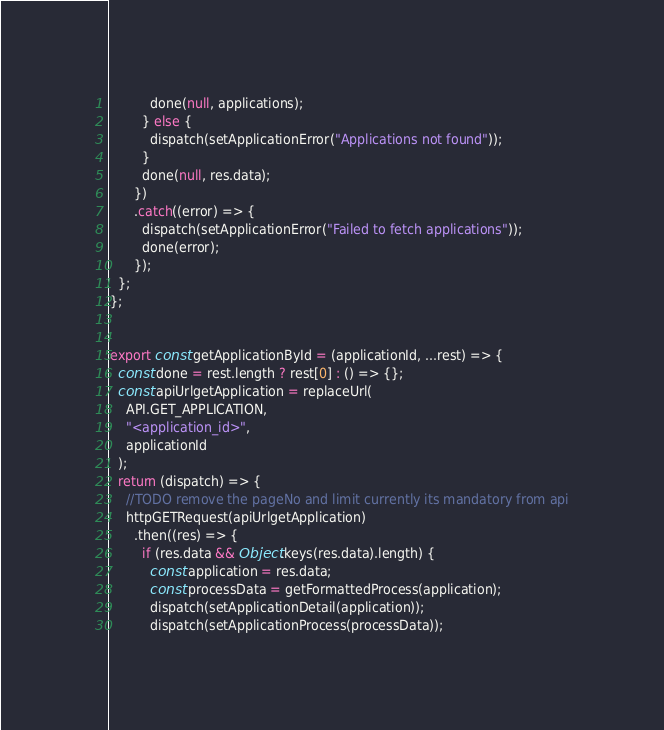Convert code to text. <code><loc_0><loc_0><loc_500><loc_500><_JavaScript_>          done(null, applications);
        } else {
          dispatch(setApplicationError("Applications not found"));
        }
        done(null, res.data);
      })
      .catch((error) => {
        dispatch(setApplicationError("Failed to fetch applications"));
        done(error);
      });
  };
};


export const getApplicationById = (applicationId, ...rest) => {
  const done = rest.length ? rest[0] : () => {};
  const apiUrlgetApplication = replaceUrl(
    API.GET_APPLICATION,
    "<application_id>",
    applicationId
  );
  return (dispatch) => {
    //TODO remove the pageNo and limit currently its mandatory from api
    httpGETRequest(apiUrlgetApplication)
      .then((res) => {
        if (res.data && Object.keys(res.data).length) {
          const application = res.data;
          const processData = getFormattedProcess(application);
          dispatch(setApplicationDetail(application));
          dispatch(setApplicationProcess(processData));</code> 